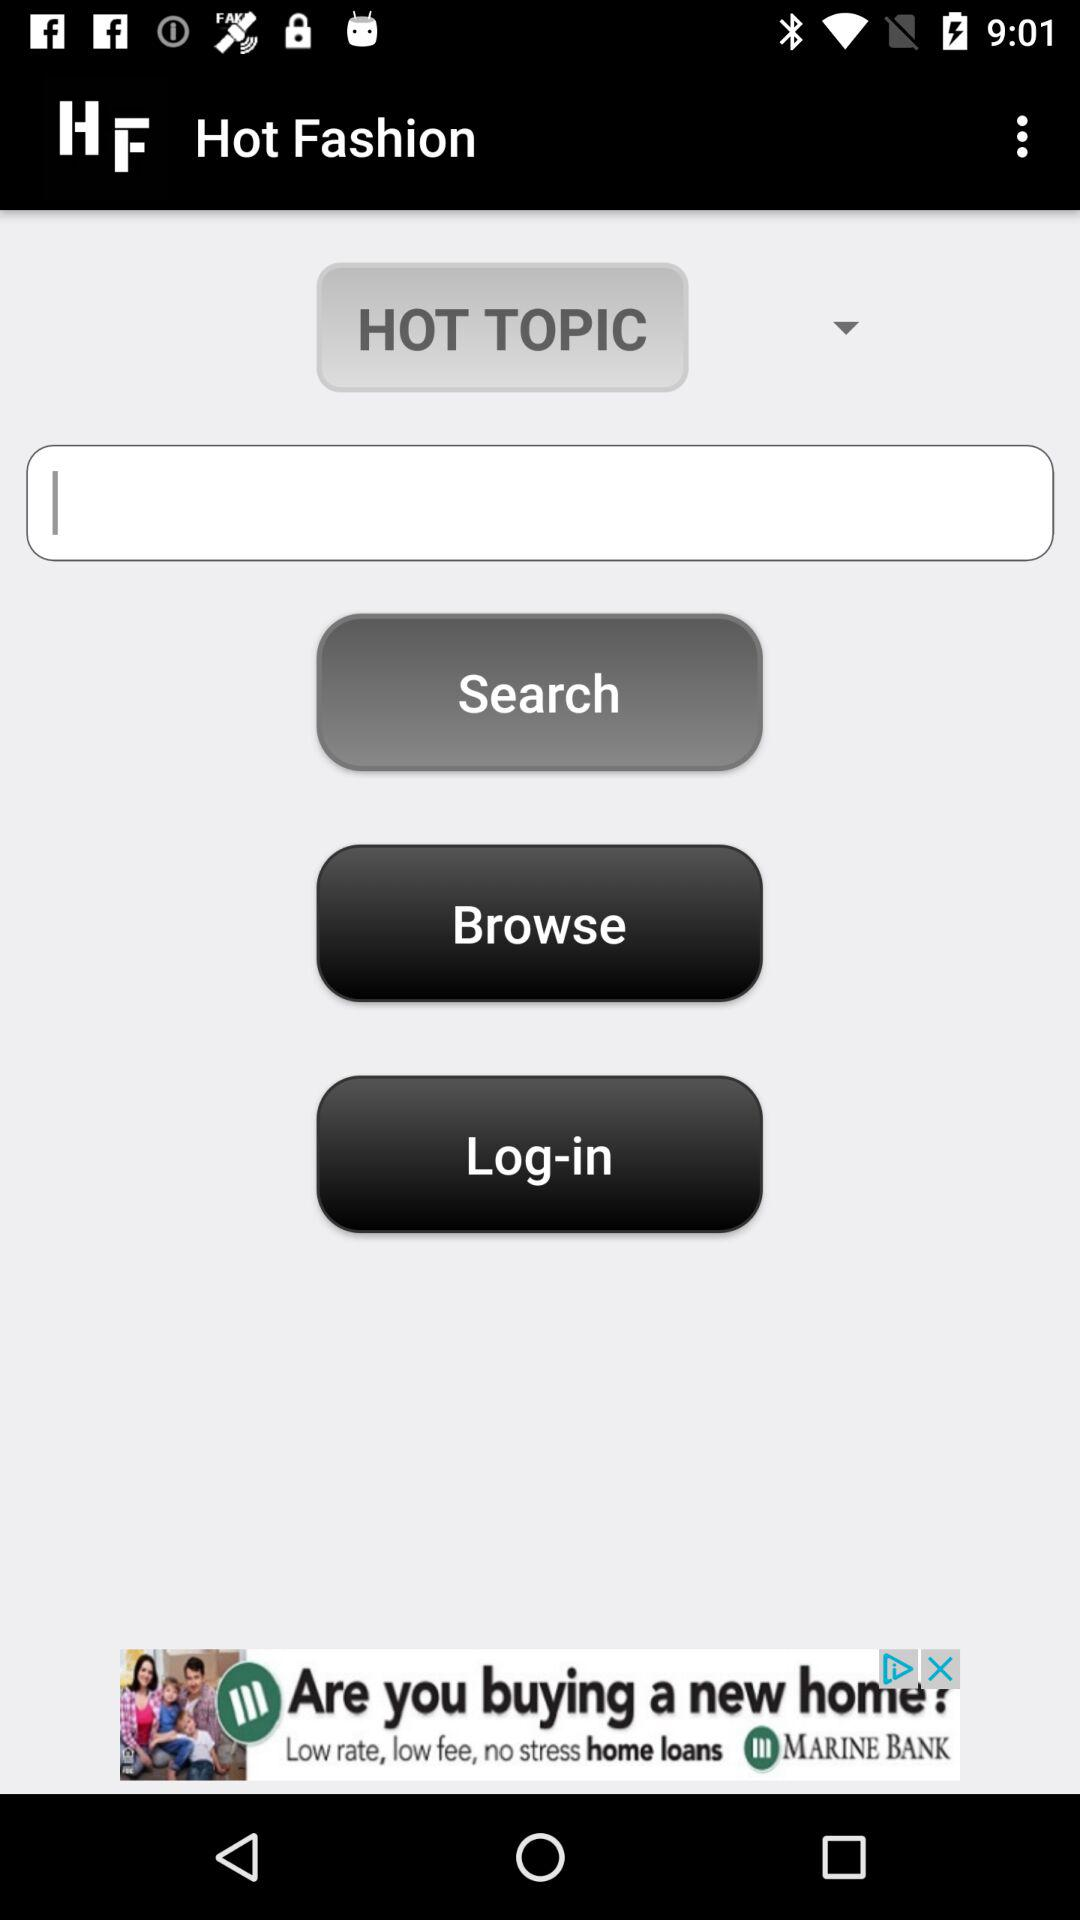What is the name of the application? The name of the application is "Hot Fashion". 